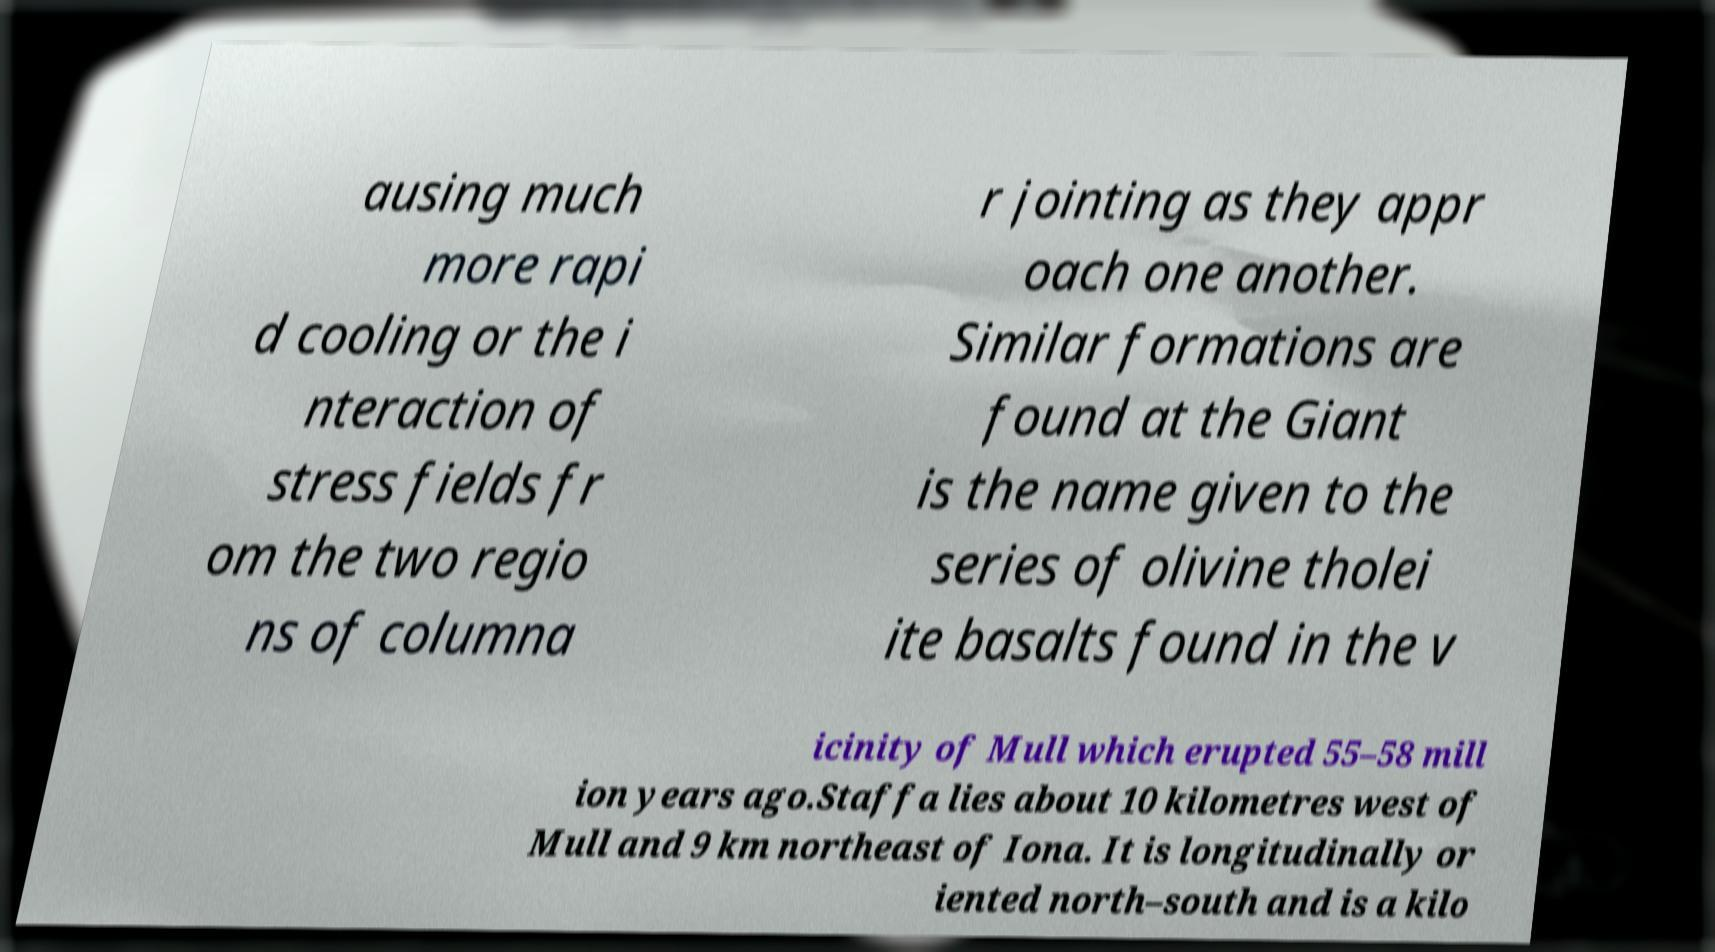Please identify and transcribe the text found in this image. ausing much more rapi d cooling or the i nteraction of stress fields fr om the two regio ns of columna r jointing as they appr oach one another. Similar formations are found at the Giant is the name given to the series of olivine tholei ite basalts found in the v icinity of Mull which erupted 55–58 mill ion years ago.Staffa lies about 10 kilometres west of Mull and 9 km northeast of Iona. It is longitudinally or iented north–south and is a kilo 